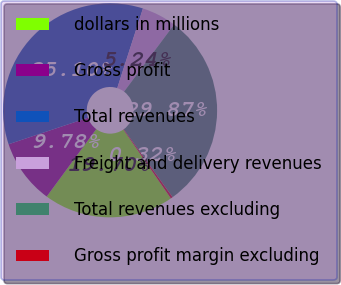<chart> <loc_0><loc_0><loc_500><loc_500><pie_chart><fcel>dollars in millions<fcel>Gross profit<fcel>Total revenues<fcel>Freight and delivery revenues<fcel>Total revenues excluding<fcel>Gross profit margin excluding<nl><fcel>19.7%<fcel>9.78%<fcel>35.1%<fcel>5.24%<fcel>29.87%<fcel>0.32%<nl></chart> 